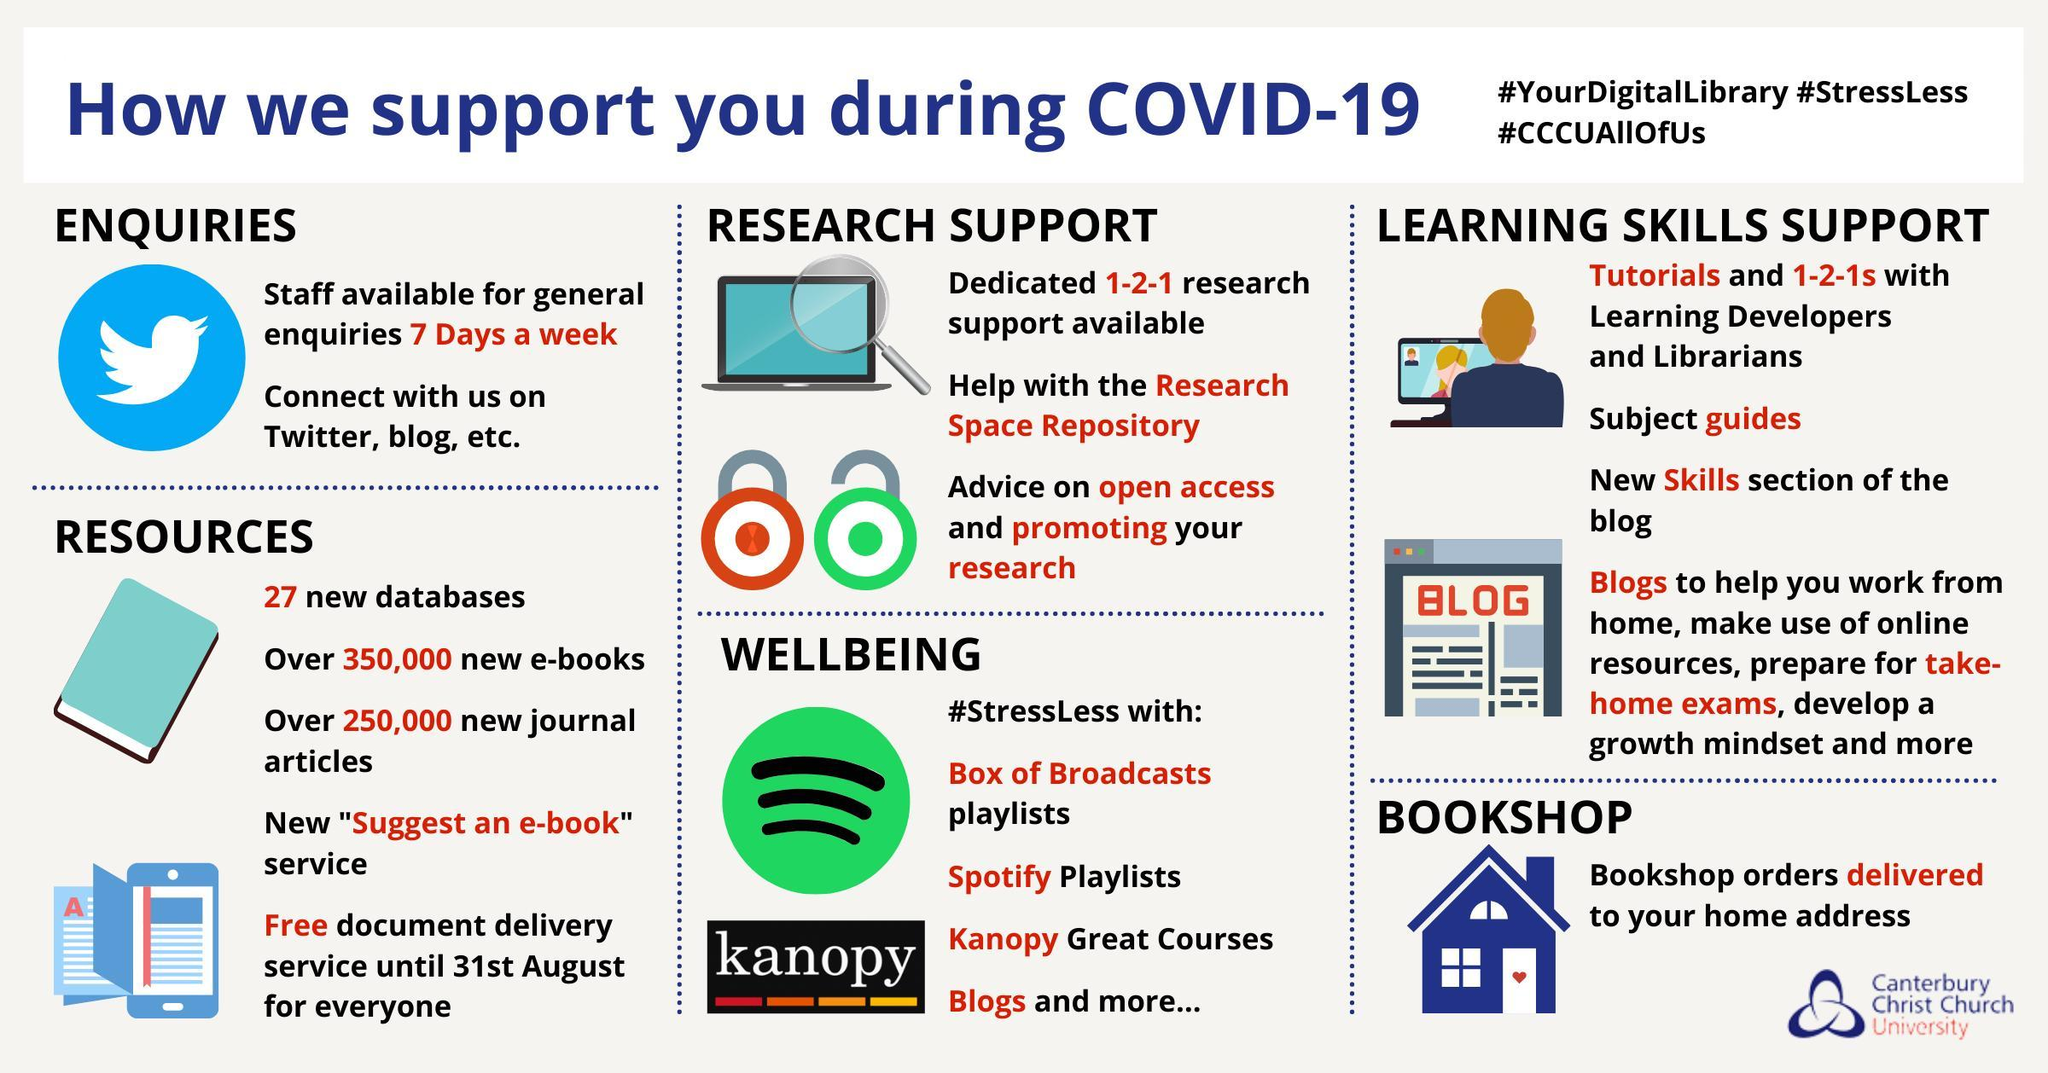What are available to help members work from home, or prepare for take-home exams?
Answer the question with a short phrase. blogs How can we connect with the library? Twitter, blog, etc. What is the second item listed under wellbeing? Spotify playlists How many items listed under resources? 5 For which service is home delivery available? bookshop orders When will the CCCU library staff be available for enquiries? 7 days a week Who will provide tutorials and 1-2-1 for learning skills? learning developers and librarians What service is available till end of August? Free document delivery 